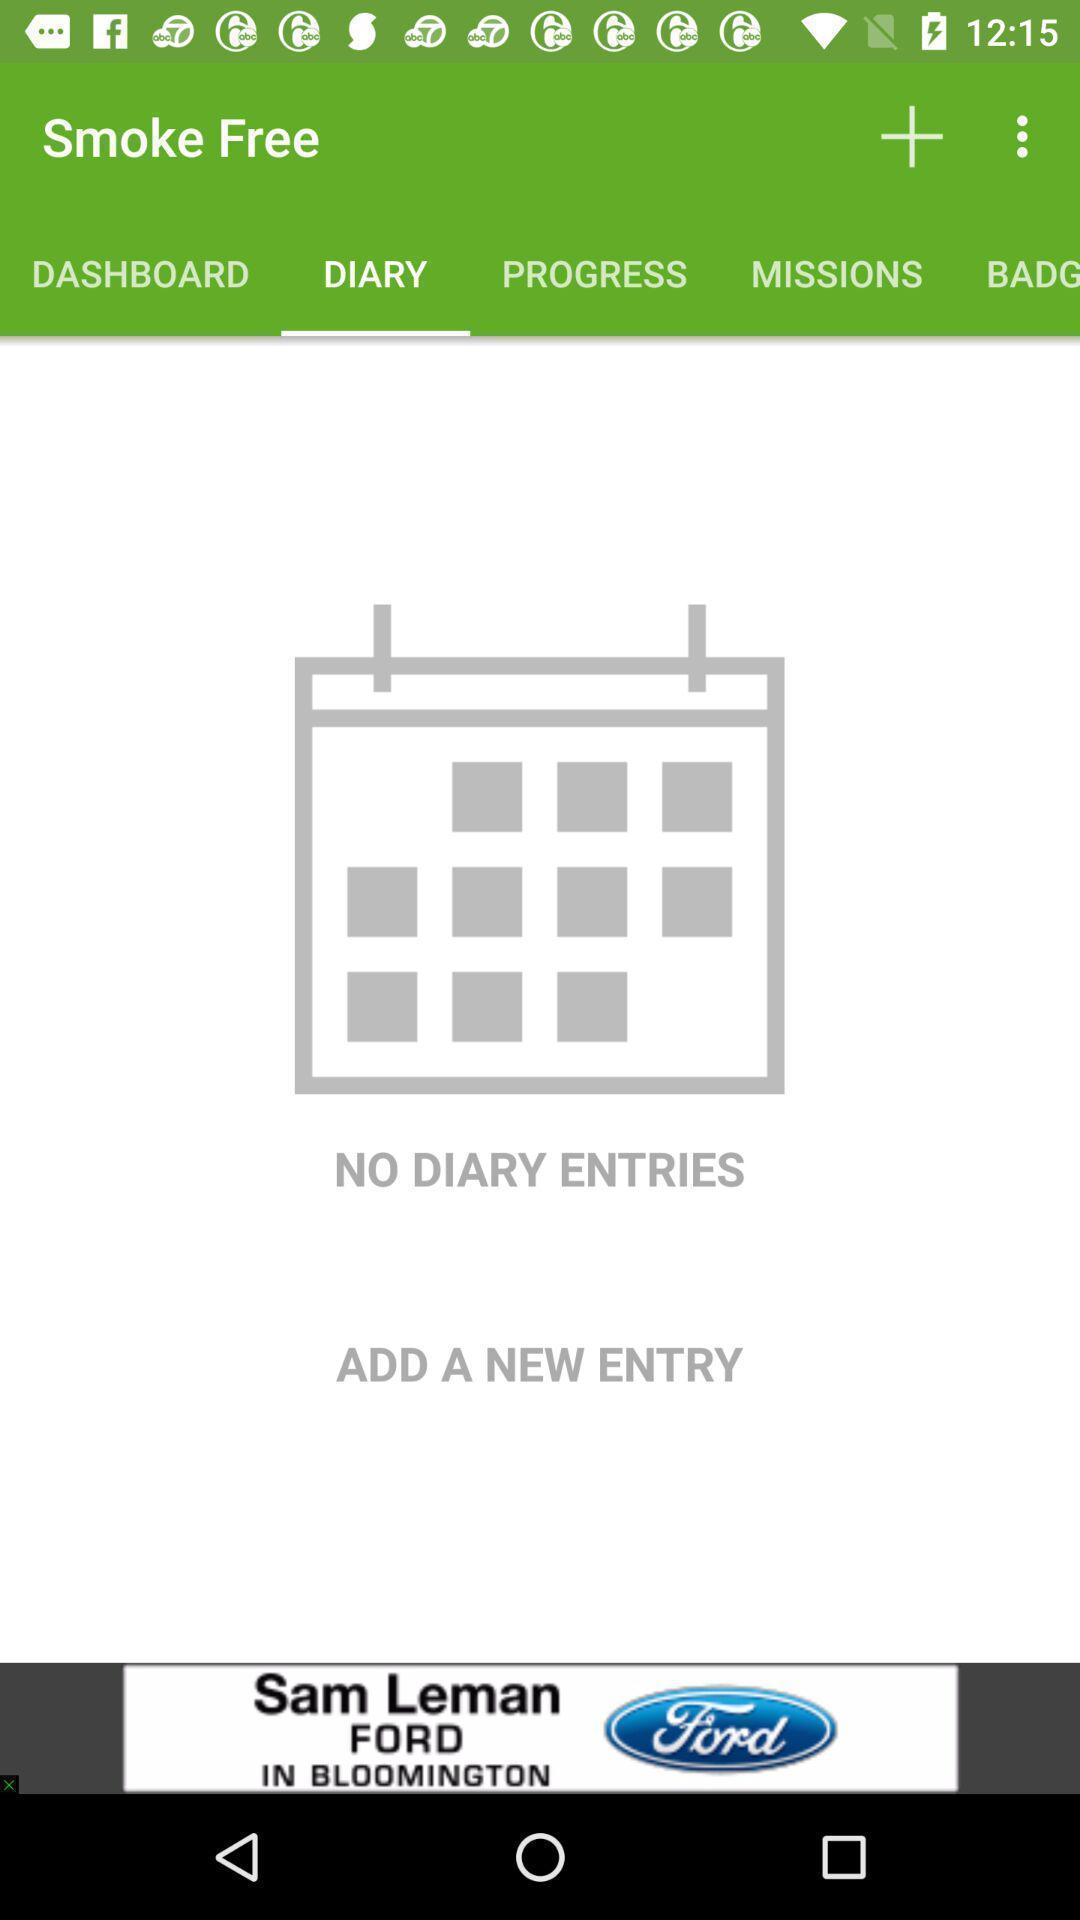Explain the elements present in this screenshot. Screen shows diary page in smoking application. 